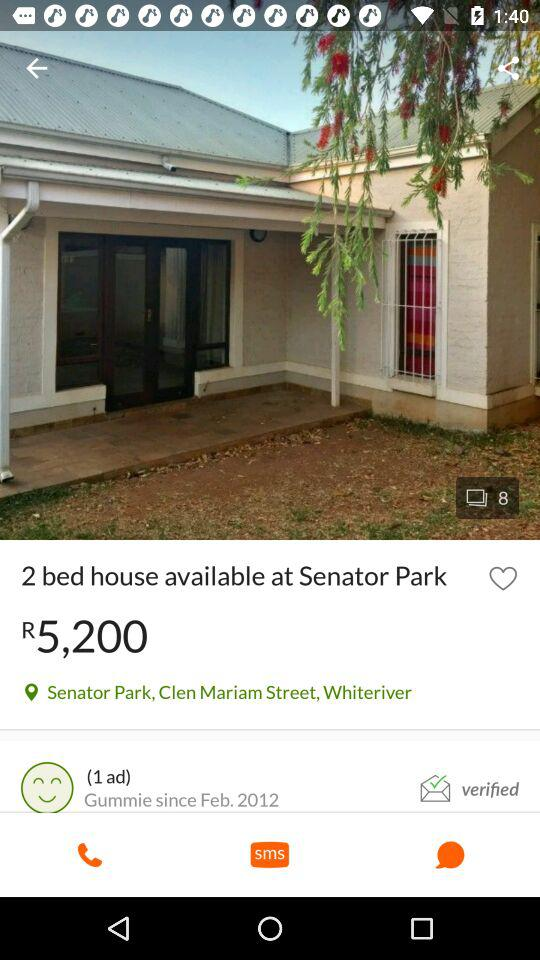What is the total number of images? The total number of images is 8. 